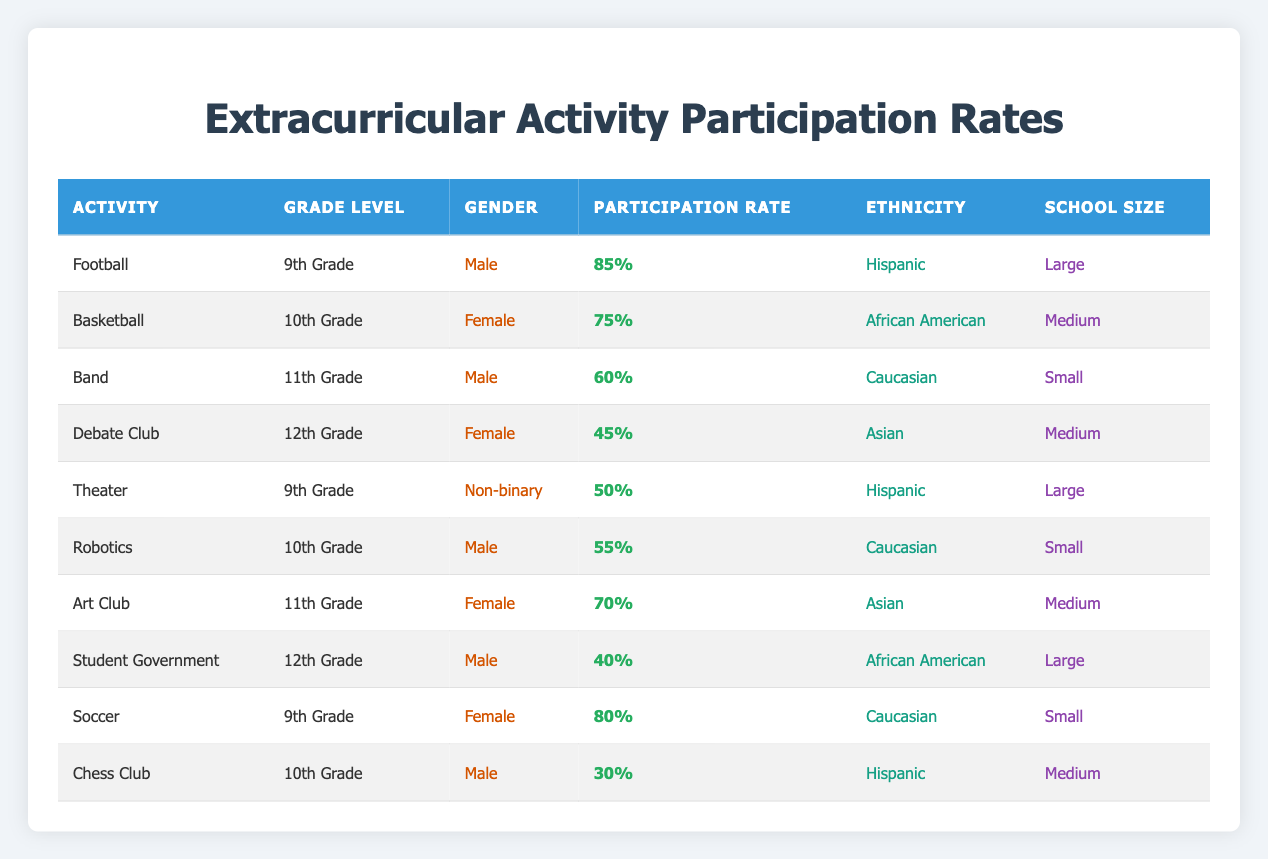What is the participation rate for Football among 9th Grade Male students? The table shows that the participation rate for Football is 85% for 9th Grade Male students.
Answer: 85% Which activity has the highest participation rate, and what is that rate? Football has the highest participation rate at 85%.
Answer: Football, 85% Does any 12th Grade activity have a participation rate greater than 50%? The table indicates that Debate Club (45%) and Student Government (40%) are both below 50%, so no 12th Grade activity exceeds that threshold.
Answer: No What is the average participation rate for Female students across all activities? The participation rates for Female students from the table are 75% (Basketball), 45% (Debate Club), 70% (Art Club), and 80% (Soccer). Summing these values gives 75 + 45 + 70 + 80 = 270, and dividing by 4 (the number of entries) results in an average of 67.5%.
Answer: 67.5% Are there any activities where the participation rate is less than 50%? The table lists Debate Club (45%) and Chess Club (30%) which both show a participation rate below 50%. Hence, the answer is yes.
Answer: Yes What is the participation rate difference between the highest and lowest rates in 10th Grade activities? The 10th Grade activities listed are Basketball (75%) and Chess Club (30%). To calculate the difference, subtract the lower rate from the higher: 75 - 30 = 45.
Answer: 45 Is there a Non-binary student participating in any extracurricular activity? The table shows that there is a Non-binary student participating in Theater with a participation rate of 50%. Therefore, the answer is yes.
Answer: Yes How many activities have a participation rate greater than 60% for Caucasian students? The table shows that Band (60%) and Soccer (80%) have rates for Caucasian students, but only Soccer exceeds 60%. So, there is one such activity.
Answer: 1 What percentage of activities for 9th Grade students have a participation rate of 75% or more? For 9th Grade, the activities are Football (85%), Theater (50%), and Soccer (80%). Out of these, Football and Soccer have rates of 75% or more, which makes 2 out of 3 activities. To find the percentage: (2/3) * 100 = 66.67%.
Answer: 66.67% 